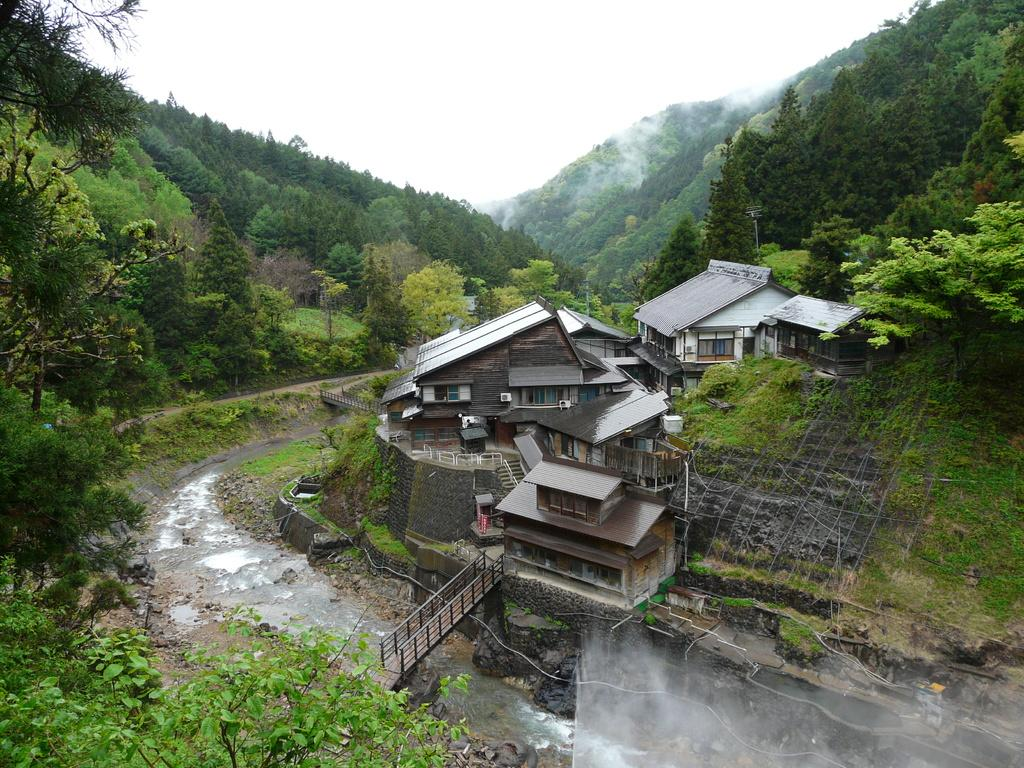What is the main subject of the image? The main subject of the image is the buildings in the center. What can be seen around the buildings? There are trees and plants around the buildings. What is visible in the background of the image? The sky is visible in the background of the image. What type of ink is used to draw the trees in the image? There is no ink present in the image, as it is a photograph or a digital representation of the scene. 